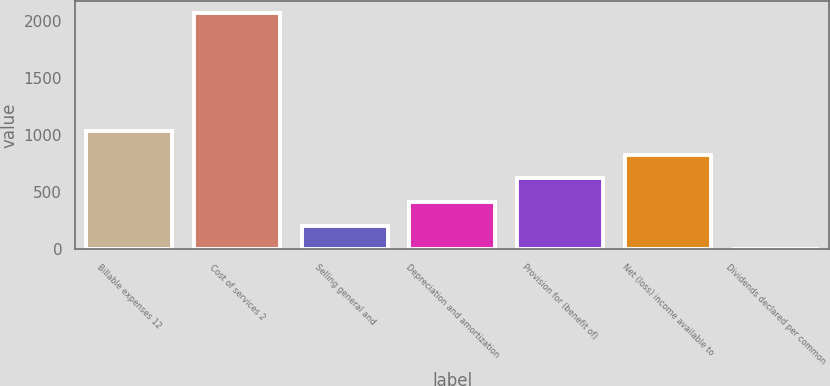Convert chart to OTSL. <chart><loc_0><loc_0><loc_500><loc_500><bar_chart><fcel>Billable expenses 12<fcel>Cost of services 2<fcel>Selling general and<fcel>Depreciation and amortization<fcel>Provision for (benefit of)<fcel>Net (loss) income available to<fcel>Dividends declared per common<nl><fcel>1035.01<fcel>2069.8<fcel>207.17<fcel>414.13<fcel>621.09<fcel>828.05<fcel>0.21<nl></chart> 